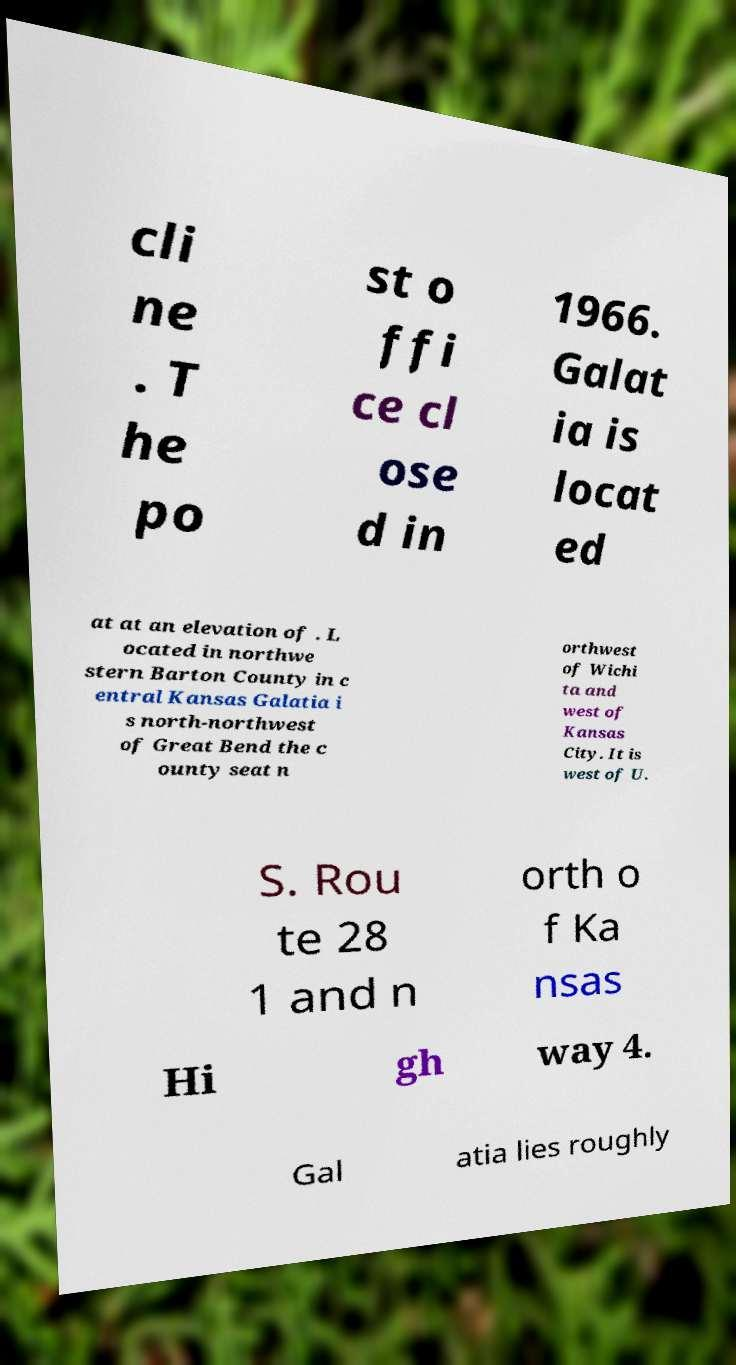Can you read and provide the text displayed in the image?This photo seems to have some interesting text. Can you extract and type it out for me? cli ne . T he po st o ffi ce cl ose d in 1966. Galat ia is locat ed at at an elevation of . L ocated in northwe stern Barton County in c entral Kansas Galatia i s north-northwest of Great Bend the c ounty seat n orthwest of Wichi ta and west of Kansas City. It is west of U. S. Rou te 28 1 and n orth o f Ka nsas Hi gh way 4. Gal atia lies roughly 